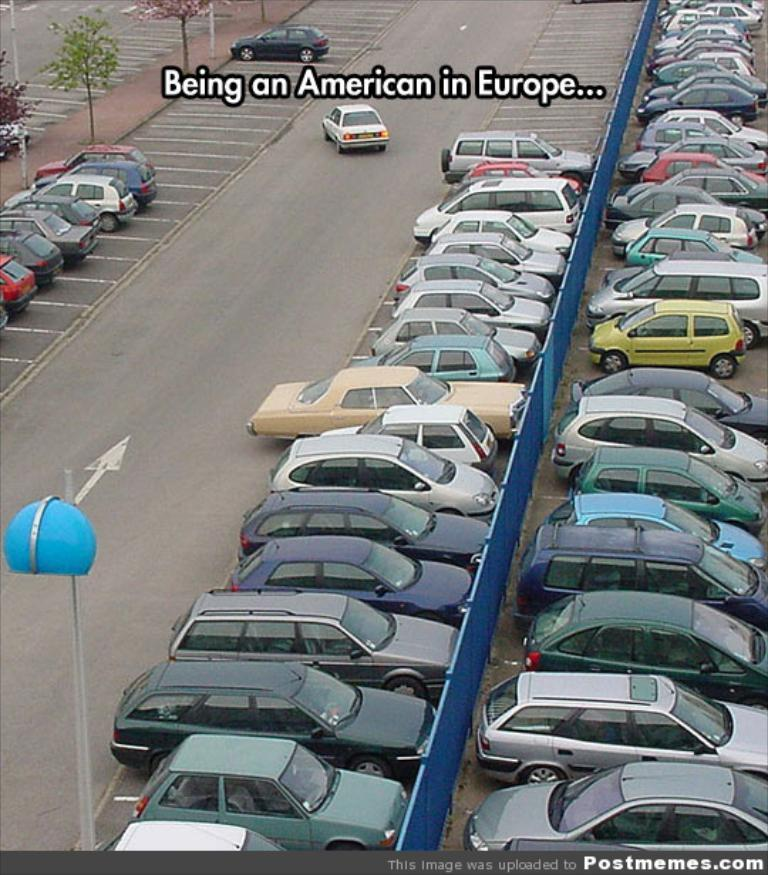What can be seen on the road in the image? There are cars on the road in the image. What type of vegetation is visible in the image? There are plants visible in the image. What is written or displayed in the image? There is some text present in the image. What object can be seen at the bottom of the image? There is a pole at the bottom of the image. Where is the pig located in the image? There is no pig present in the image. What shape is the circle in the image? There is no circle present in the image. 